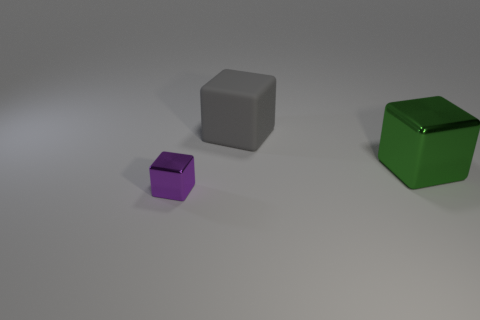Add 2 tiny green shiny cylinders. How many objects exist? 5 Add 1 small objects. How many small objects are left? 2 Add 3 small brown matte cubes. How many small brown matte cubes exist? 3 Subtract 0 cyan cylinders. How many objects are left? 3 Subtract all large gray things. Subtract all tiny metal blocks. How many objects are left? 1 